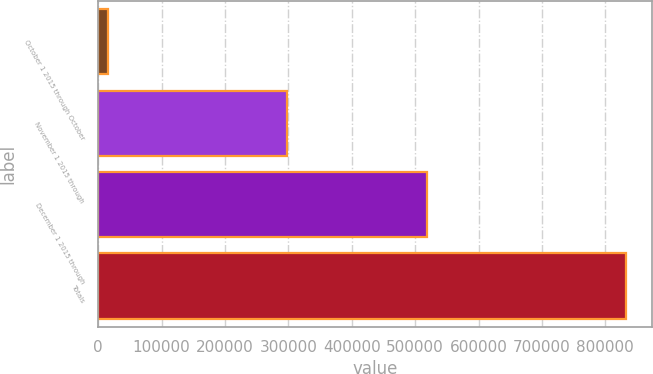<chart> <loc_0><loc_0><loc_500><loc_500><bar_chart><fcel>October 1 2015 through October<fcel>November 1 2015 through<fcel>December 1 2015 through<fcel>Totals<nl><fcel>14932<fcel>298349<fcel>519400<fcel>832681<nl></chart> 